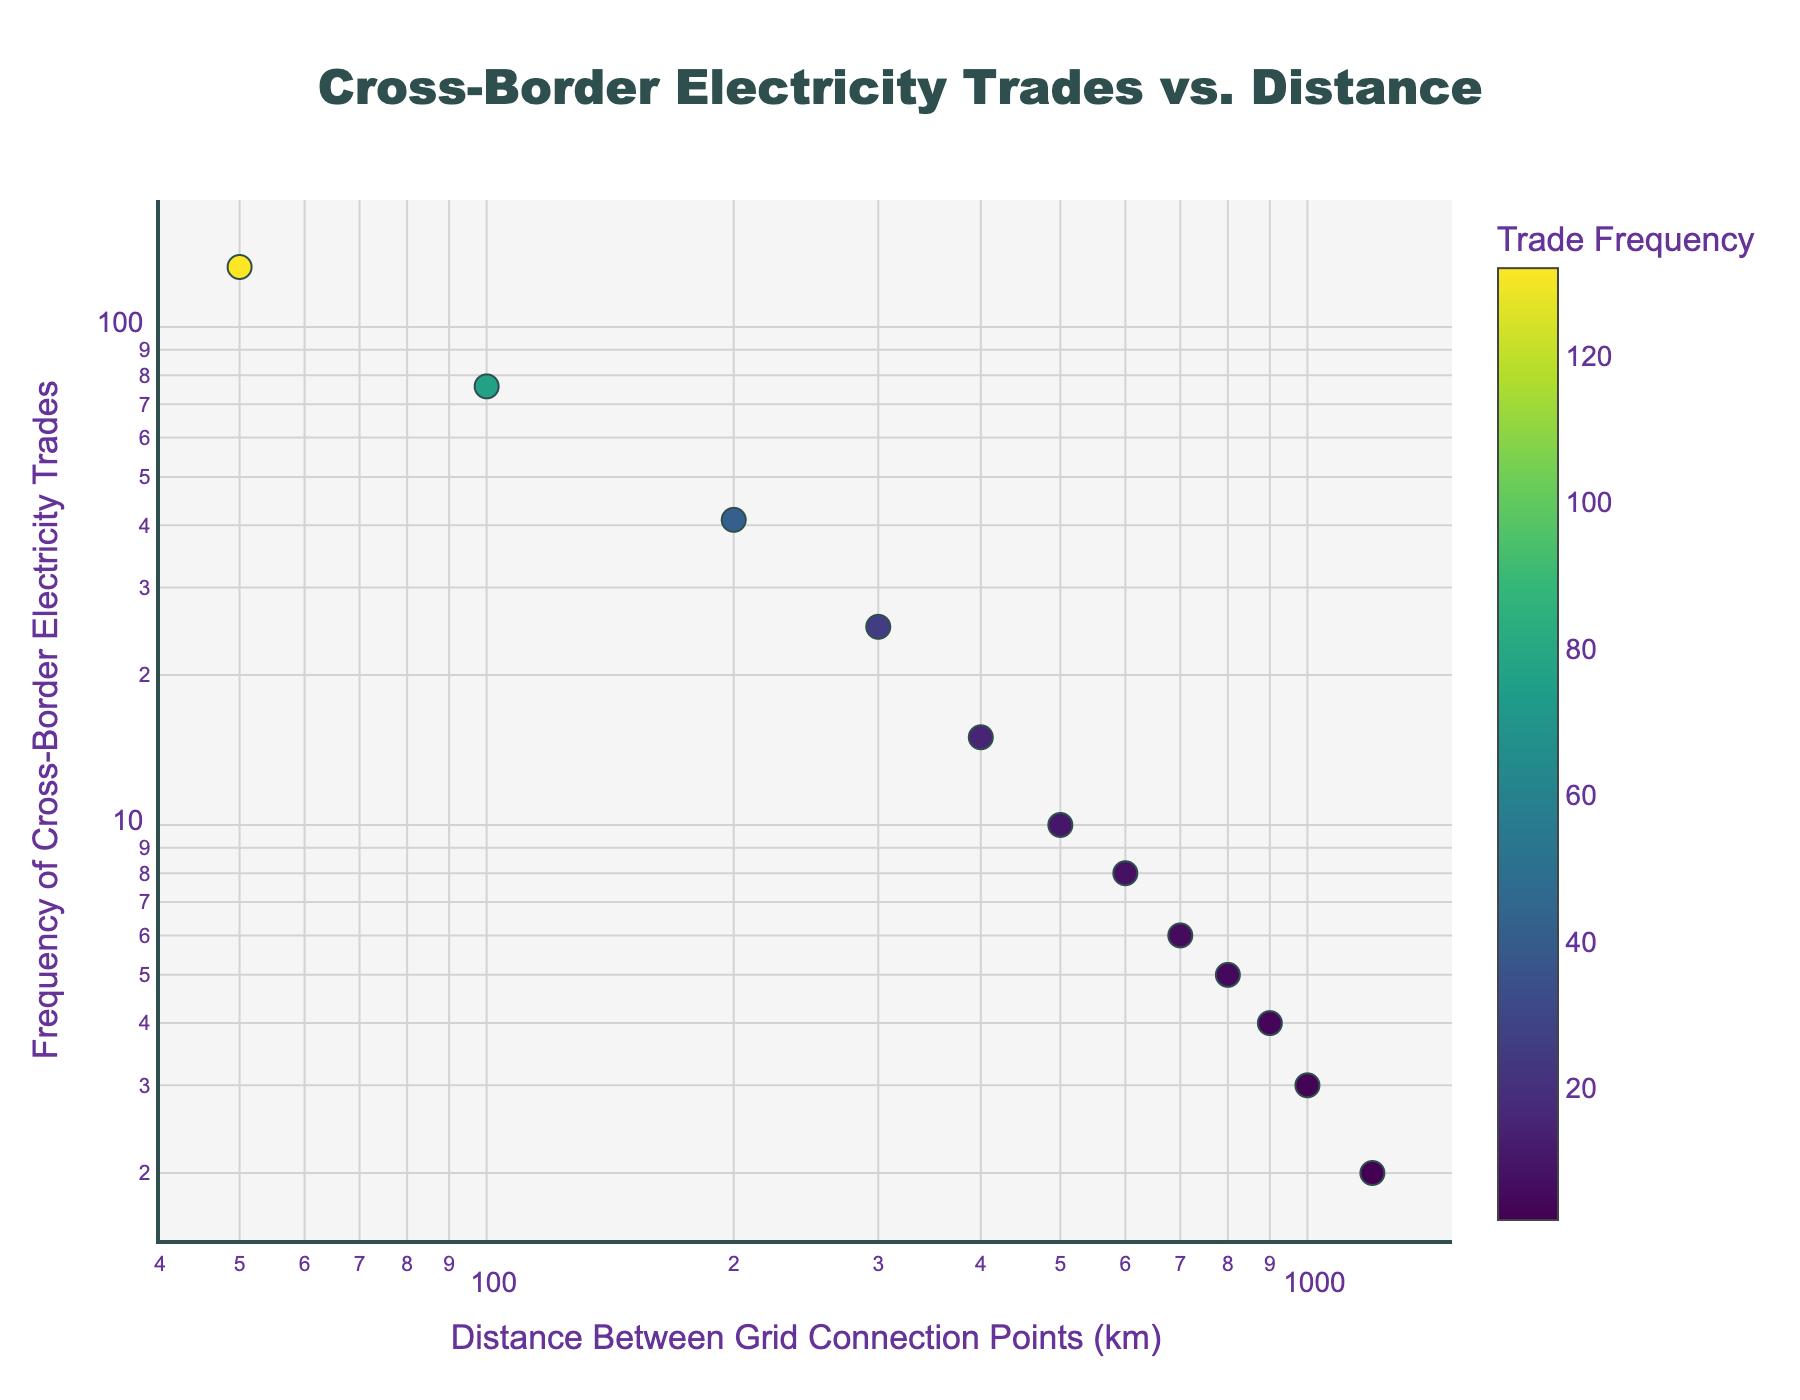What is the title of the plot? The title of the plot is located at the top center of the figure. It provides a brief description of the data presented in the plot.
Answer: Cross-Border Electricity Trades vs. Distance How many data points are shown in the plot? Count the number of markers on the scatter plot, which represent the data points.
Answer: 12 What is the range of the x-axis in the plot? Look at the x-axis to determine the range of distances between grid connection points. The x-axis has a log scale, so examine the minimum and maximum distance values.
Answer: 50 km to 1200 km What is the trade frequency at a distance of 100 km? Identify the marker on the plot where the distance value is 100 km and read the corresponding trade frequency from the y-axis.
Answer: 76 Which distance has the lowest frequency of cross-border electricity trades? Find the marker with the smallest y-value on the plot and read the corresponding distance from the x-axis.
Answer: 1200 km Which distance has the highest frequency of cross-border electricity trades? Find the marker with the largest y-value on the plot and read the corresponding distance from the x-axis.
Answer: 50 km What is the average trade frequency for distances less than 400 km? Identify the data points where the distance is less than 400 km and calculate the average trade frequency for these points. (132 + 76 + 41 + 25) / 4 = 68.5
Answer: 68.5 How does the trade frequency change as the distance increases? Observe the trend in the scatter plot. As the distance between grid connection points increases, the frequency of cross-border electricity trades generally decreases.
Answer: Decreases What is the trade frequency for the point with the second highest distance value? Identify the distance value just before the highest one (1200 km), which is 1000 km, and read the corresponding trade frequency.
Answer: 3 